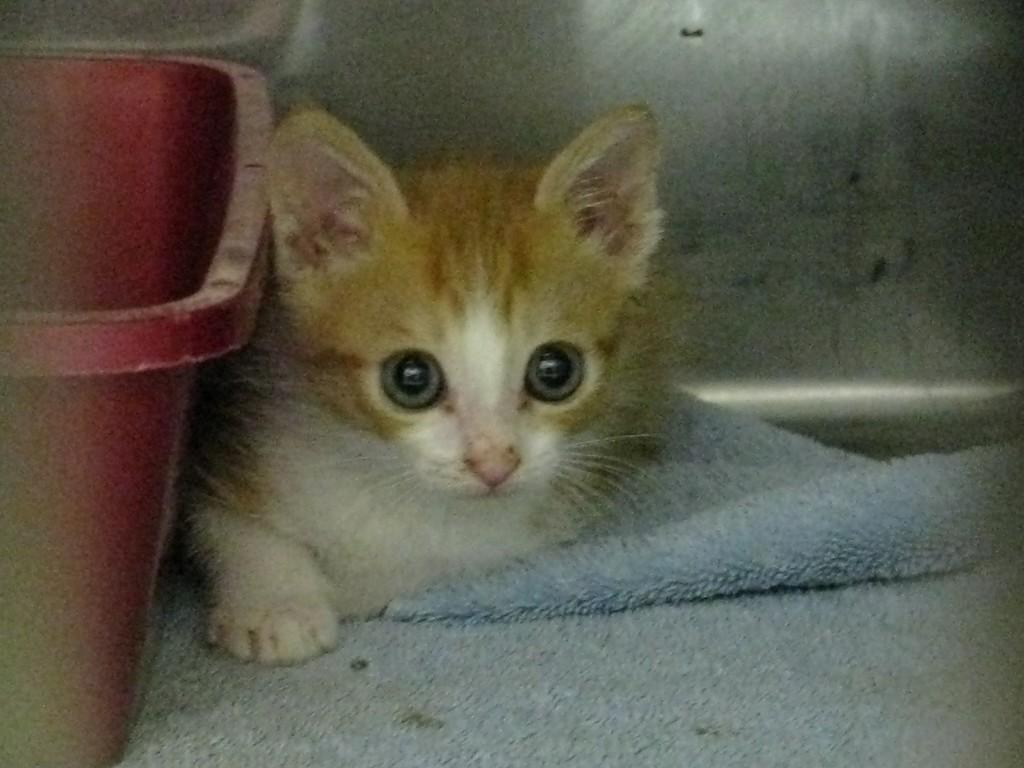What is the main subject in the center of the image? There is a cat in the center of the image. What is the cat sitting on? The cat is on a mat. What can be seen on the left side of the image? There is a tub on the left side of the image. How many roots can be seen growing from the cat's tail in the image? There are no roots visible in the image, as it features a cat on a mat and a tub on the left side. 